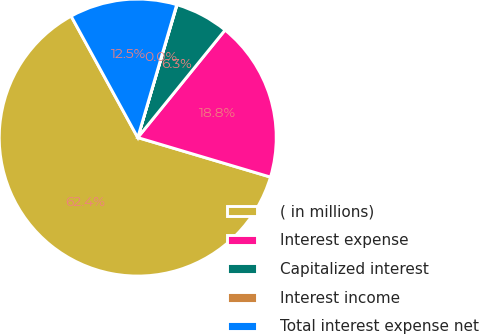<chart> <loc_0><loc_0><loc_500><loc_500><pie_chart><fcel>( in millions)<fcel>Interest expense<fcel>Capitalized interest<fcel>Interest income<fcel>Total interest expense net<nl><fcel>62.41%<fcel>18.75%<fcel>6.28%<fcel>0.04%<fcel>12.52%<nl></chart> 